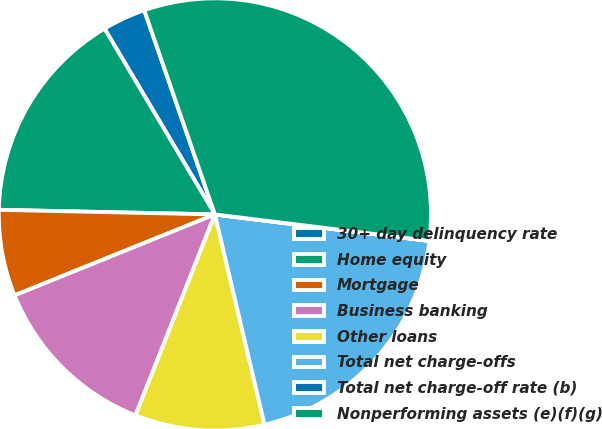<chart> <loc_0><loc_0><loc_500><loc_500><pie_chart><fcel>30+ day delinquency rate<fcel>Home equity<fcel>Mortgage<fcel>Business banking<fcel>Other loans<fcel>Total net charge-offs<fcel>Total net charge-off rate (b)<fcel>Nonperforming assets (e)(f)(g)<nl><fcel>3.23%<fcel>16.13%<fcel>6.45%<fcel>12.9%<fcel>9.68%<fcel>19.35%<fcel>0.01%<fcel>32.25%<nl></chart> 